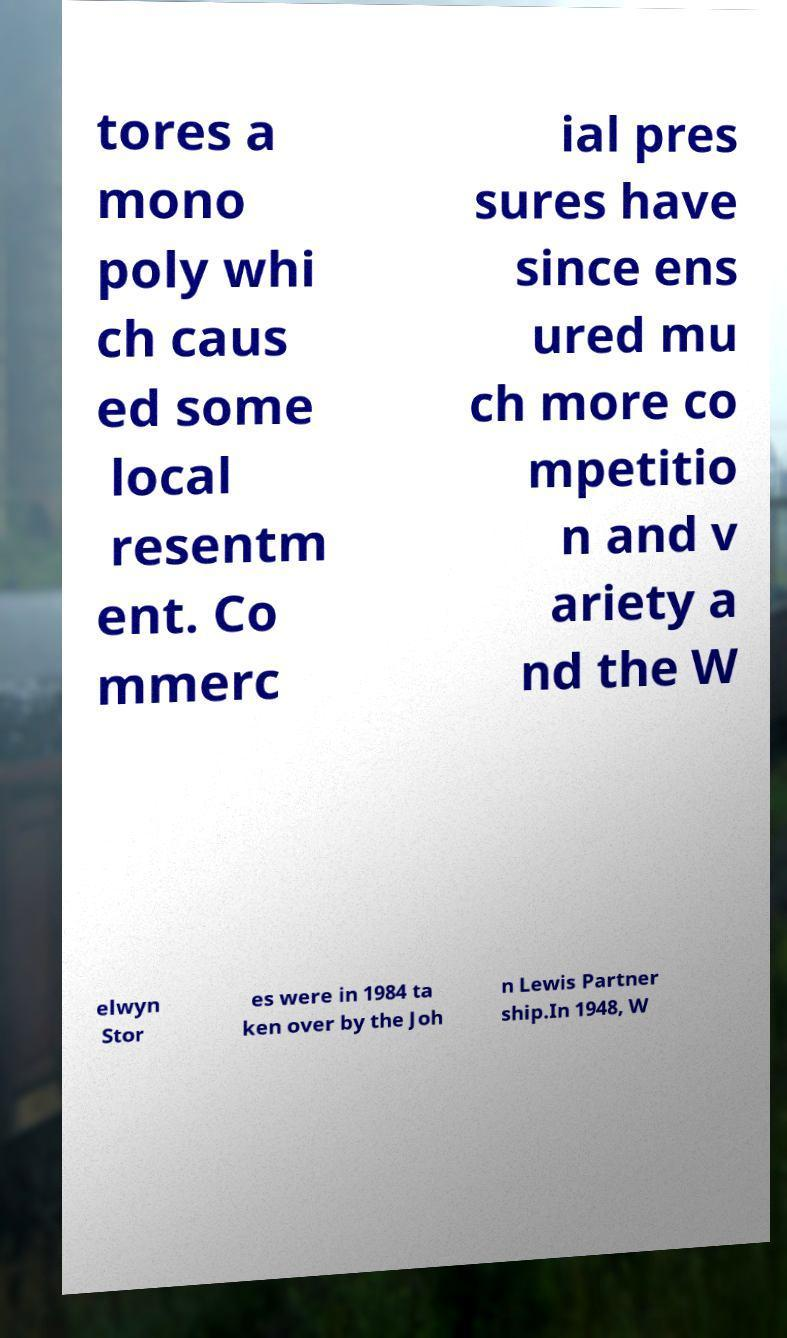Please identify and transcribe the text found in this image. tores a mono poly whi ch caus ed some local resentm ent. Co mmerc ial pres sures have since ens ured mu ch more co mpetitio n and v ariety a nd the W elwyn Stor es were in 1984 ta ken over by the Joh n Lewis Partner ship.In 1948, W 